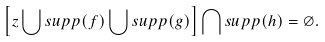<formula> <loc_0><loc_0><loc_500><loc_500>\left [ z \bigcup s u p p ( f ) \bigcup s u p p ( g ) \right ] \bigcap s u p p ( h ) = \varnothing .</formula> 